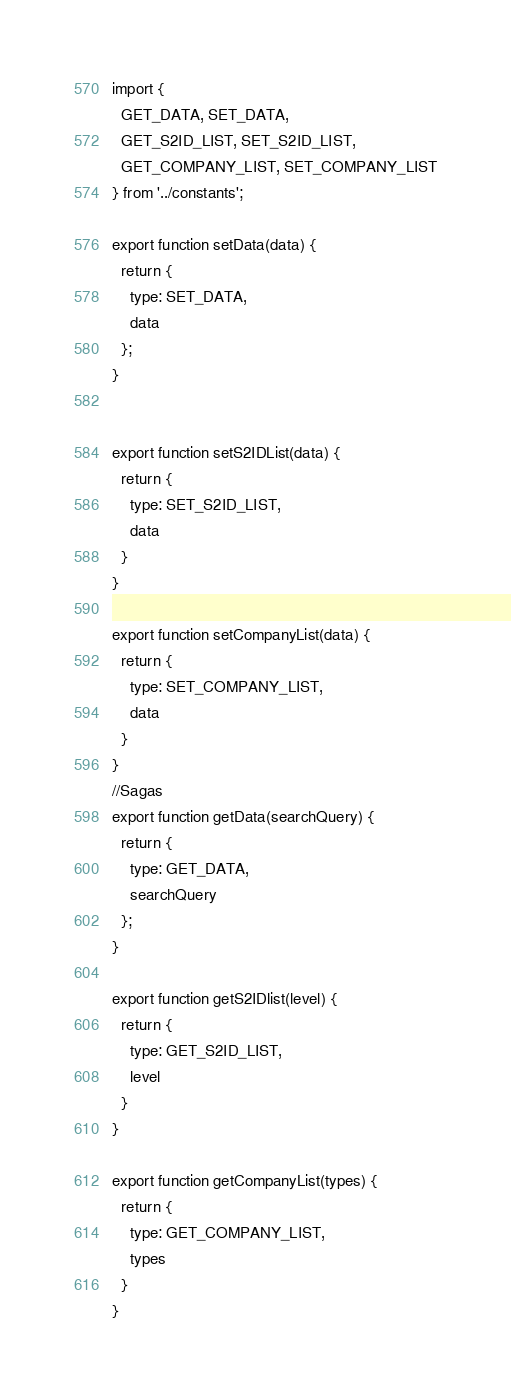Convert code to text. <code><loc_0><loc_0><loc_500><loc_500><_JavaScript_>import {
  GET_DATA, SET_DATA,
  GET_S2ID_LIST, SET_S2ID_LIST,
  GET_COMPANY_LIST, SET_COMPANY_LIST
} from '../constants';

export function setData(data) {
  return {
    type: SET_DATA,
    data
  };
}


export function setS2IDList(data) {
  return {
    type: SET_S2ID_LIST,
    data
  }
}

export function setCompanyList(data) {
  return {
    type: SET_COMPANY_LIST,
    data
  }
}
//Sagas
export function getData(searchQuery) {
  return {
    type: GET_DATA,
    searchQuery
  };
}

export function getS2IDlist(level) {
  return {
    type: GET_S2ID_LIST,
    level
  }
}

export function getCompanyList(types) {
  return {
    type: GET_COMPANY_LIST,
    types
  }
}</code> 